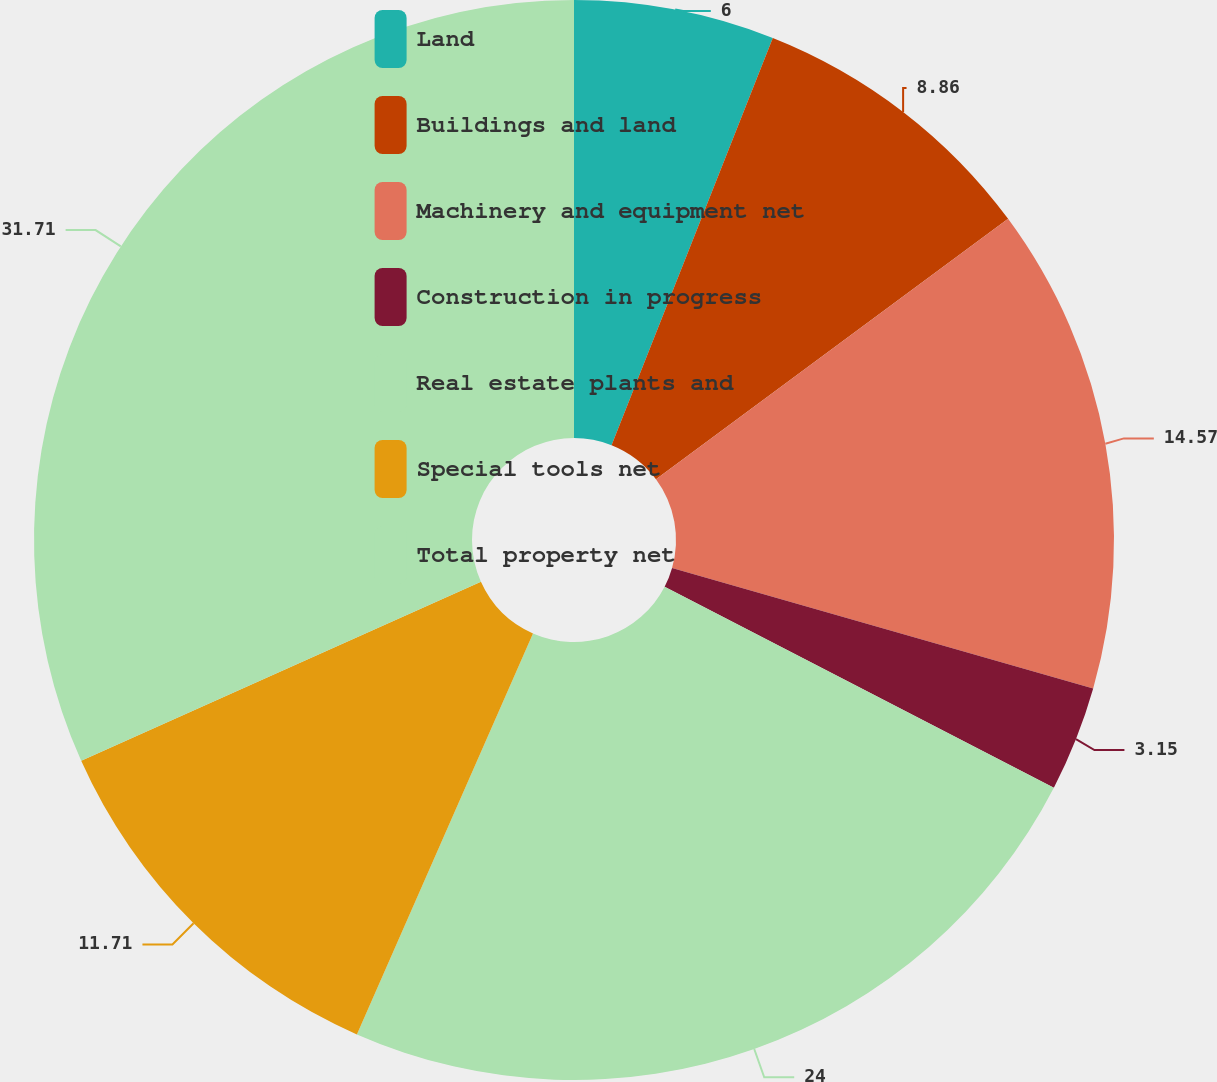Convert chart. <chart><loc_0><loc_0><loc_500><loc_500><pie_chart><fcel>Land<fcel>Buildings and land<fcel>Machinery and equipment net<fcel>Construction in progress<fcel>Real estate plants and<fcel>Special tools net<fcel>Total property net<nl><fcel>6.0%<fcel>8.86%<fcel>14.57%<fcel>3.15%<fcel>24.0%<fcel>11.71%<fcel>31.7%<nl></chart> 